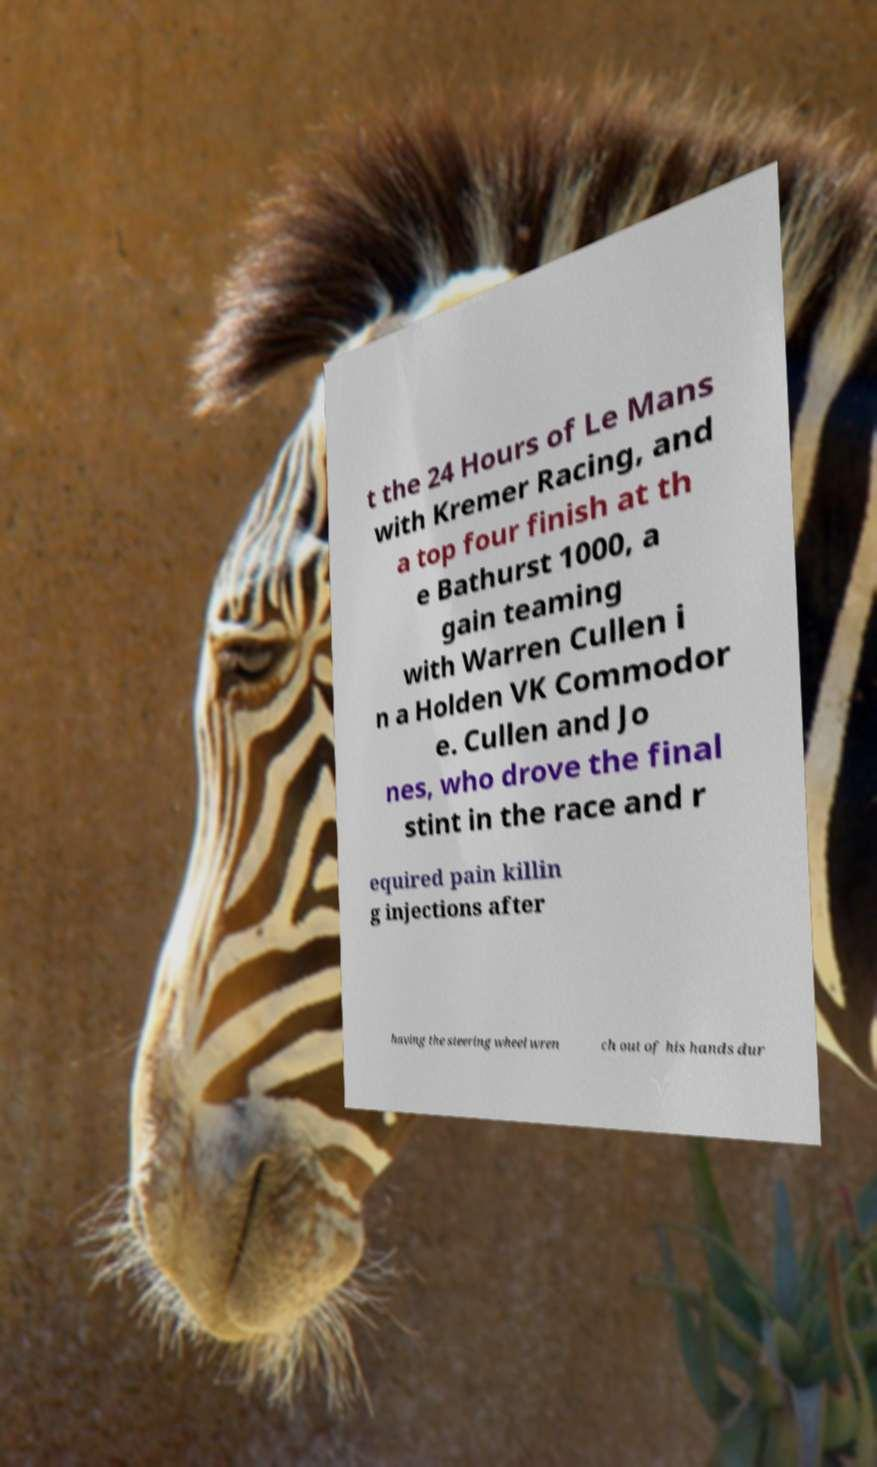Can you accurately transcribe the text from the provided image for me? t the 24 Hours of Le Mans with Kremer Racing, and a top four finish at th e Bathurst 1000, a gain teaming with Warren Cullen i n a Holden VK Commodor e. Cullen and Jo nes, who drove the final stint in the race and r equired pain killin g injections after having the steering wheel wren ch out of his hands dur 